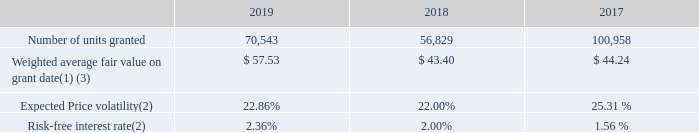PSUs – Total Shareholder Return (TSR)
The PSUs granted based on TSR are contingently awarded and will be payable in shares of the Company’s common stock subject to the condition that the number of PSUs, if any, earned by the employees upon the expiration of a three-year award performance period is dependent on the Company’s TSR ranking relative to a peer group of companies. The fair value of the PSUs based on TSR was estimated on the grant date using a Monte Carlo Simulation. Other assumptions include the expected volatility of all companies included in the TSR, the historical share price returns analysis of all companies included in the TSR and assumes dividends are reinvested. The expected volatility was based on the historical volatility for a period of time that approximates the duration between the valuation date and the end of the performance period. The risk-free interest rate is based on the Zero-Coupon Treasury STRIP yield curve matching the term from the valuation date to the end of the performance period. Compensation expense for the PSUs based on TSR (which is considered a market condition) is a fixed amount determined at the grant date fair value and is recognized 100% over the three-year award performance period regardless of whether PSUs are awarded at the end of the award performance period.
The number of PSUs granted based on TSR and the assumptions used to calculate the grant date fair value of the PSUs based on TSR are shown in the following table:
(1) For 2019, this represents the weighted average fair value for PSU awards approved during the first and third quarter.
(2) For 2019, values represent weighted average assumptions for PSU awards approved during the first and third quarter.
(3) On May 18, 2017, the O&C Committee approved a change in the vesting policy regarding the existing 2017 Three year PSU Awards for Ilham Kadri. The modified vesting terms resulted in award modification accounting treatment. The weighted average fair value on grant date reflects the impact of the fair value on date of modification for these awards.
How was the fair value of the PSUs based on TSR estimated? A monte carlo simulation. What does the table represent? The number of psus granted based on tsr and the assumptions used to calculate the grant date fair value of the psus based on tsr. On may 18, 2017,  what did the O&C Committee approve? A change in the vesting policy regarding the existing 2017 three year psu awards for ilham kadri. What is the average Risk-free interest rate for the 3 years?
Answer scale should be: percent. (2.36+2.00+1.56)/3
Answer: 1.97. What is the number of units granted for 2019 expressed as a percentage of all units granted?
Answer scale should be: percent. 70,543/(70,543+56,829+100,958)
Answer: 30.9. What is the average Number of units granted for the 3 years? (70,543+56,829+100,958)/3
Answer: 76110. 